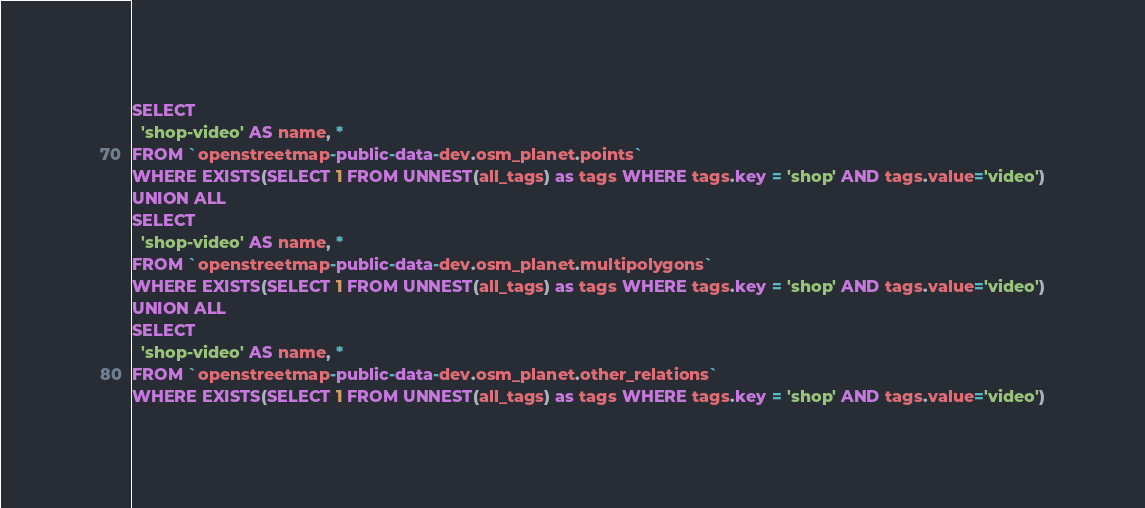<code> <loc_0><loc_0><loc_500><loc_500><_SQL_>SELECT
  'shop-video' AS name, *
FROM `openstreetmap-public-data-dev.osm_planet.points`
WHERE EXISTS(SELECT 1 FROM UNNEST(all_tags) as tags WHERE tags.key = 'shop' AND tags.value='video')
UNION ALL
SELECT
  'shop-video' AS name, *
FROM `openstreetmap-public-data-dev.osm_planet.multipolygons`
WHERE EXISTS(SELECT 1 FROM UNNEST(all_tags) as tags WHERE tags.key = 'shop' AND tags.value='video')
UNION ALL
SELECT
  'shop-video' AS name, *
FROM `openstreetmap-public-data-dev.osm_planet.other_relations`
WHERE EXISTS(SELECT 1 FROM UNNEST(all_tags) as tags WHERE tags.key = 'shop' AND tags.value='video')

</code> 